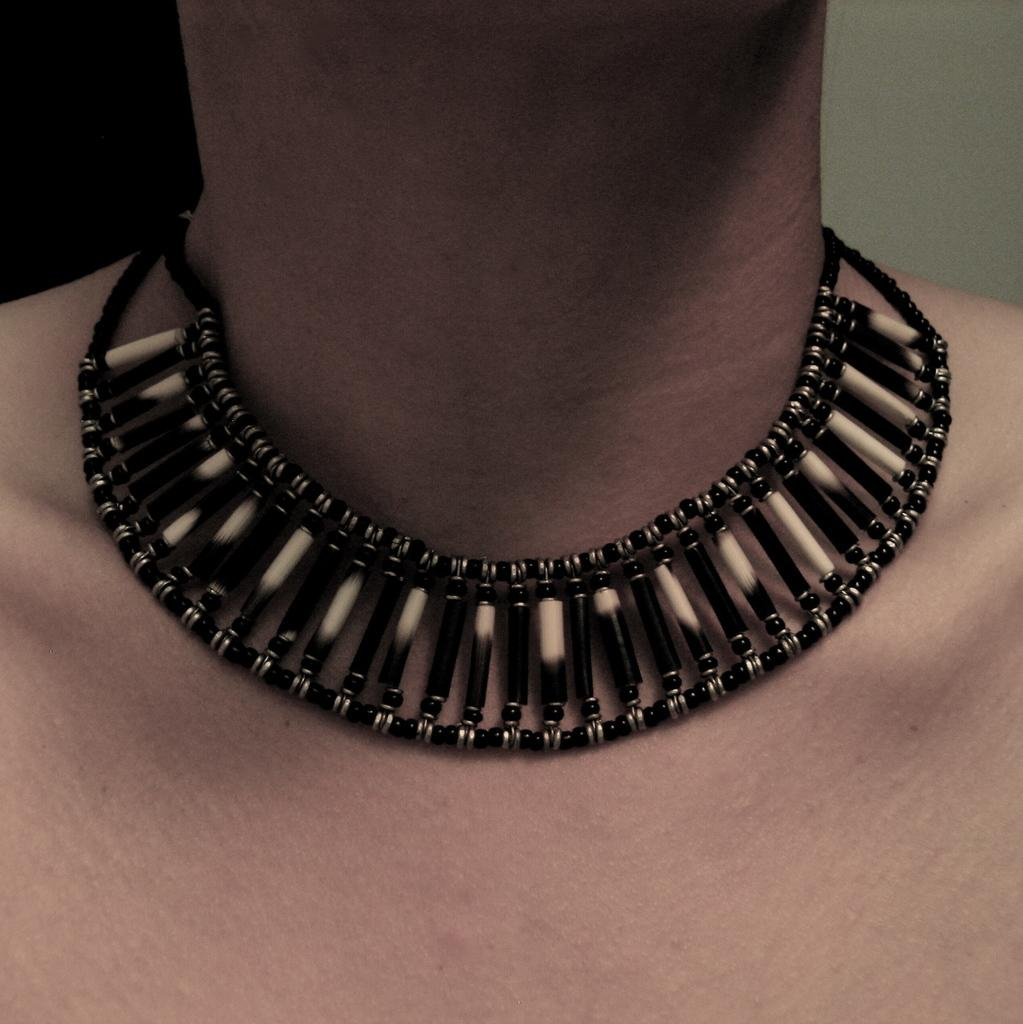Who or what is present in the image? There is a person in the image. What is the person wearing in the image? The person is wearing a necklace in the image. What can be seen in the background of the image? There is a wall in the background of the image. What type of pipe can be seen in the image? There is no pipe present in the image. How many buckets are visible in the image? There are no buckets visible in the image. 